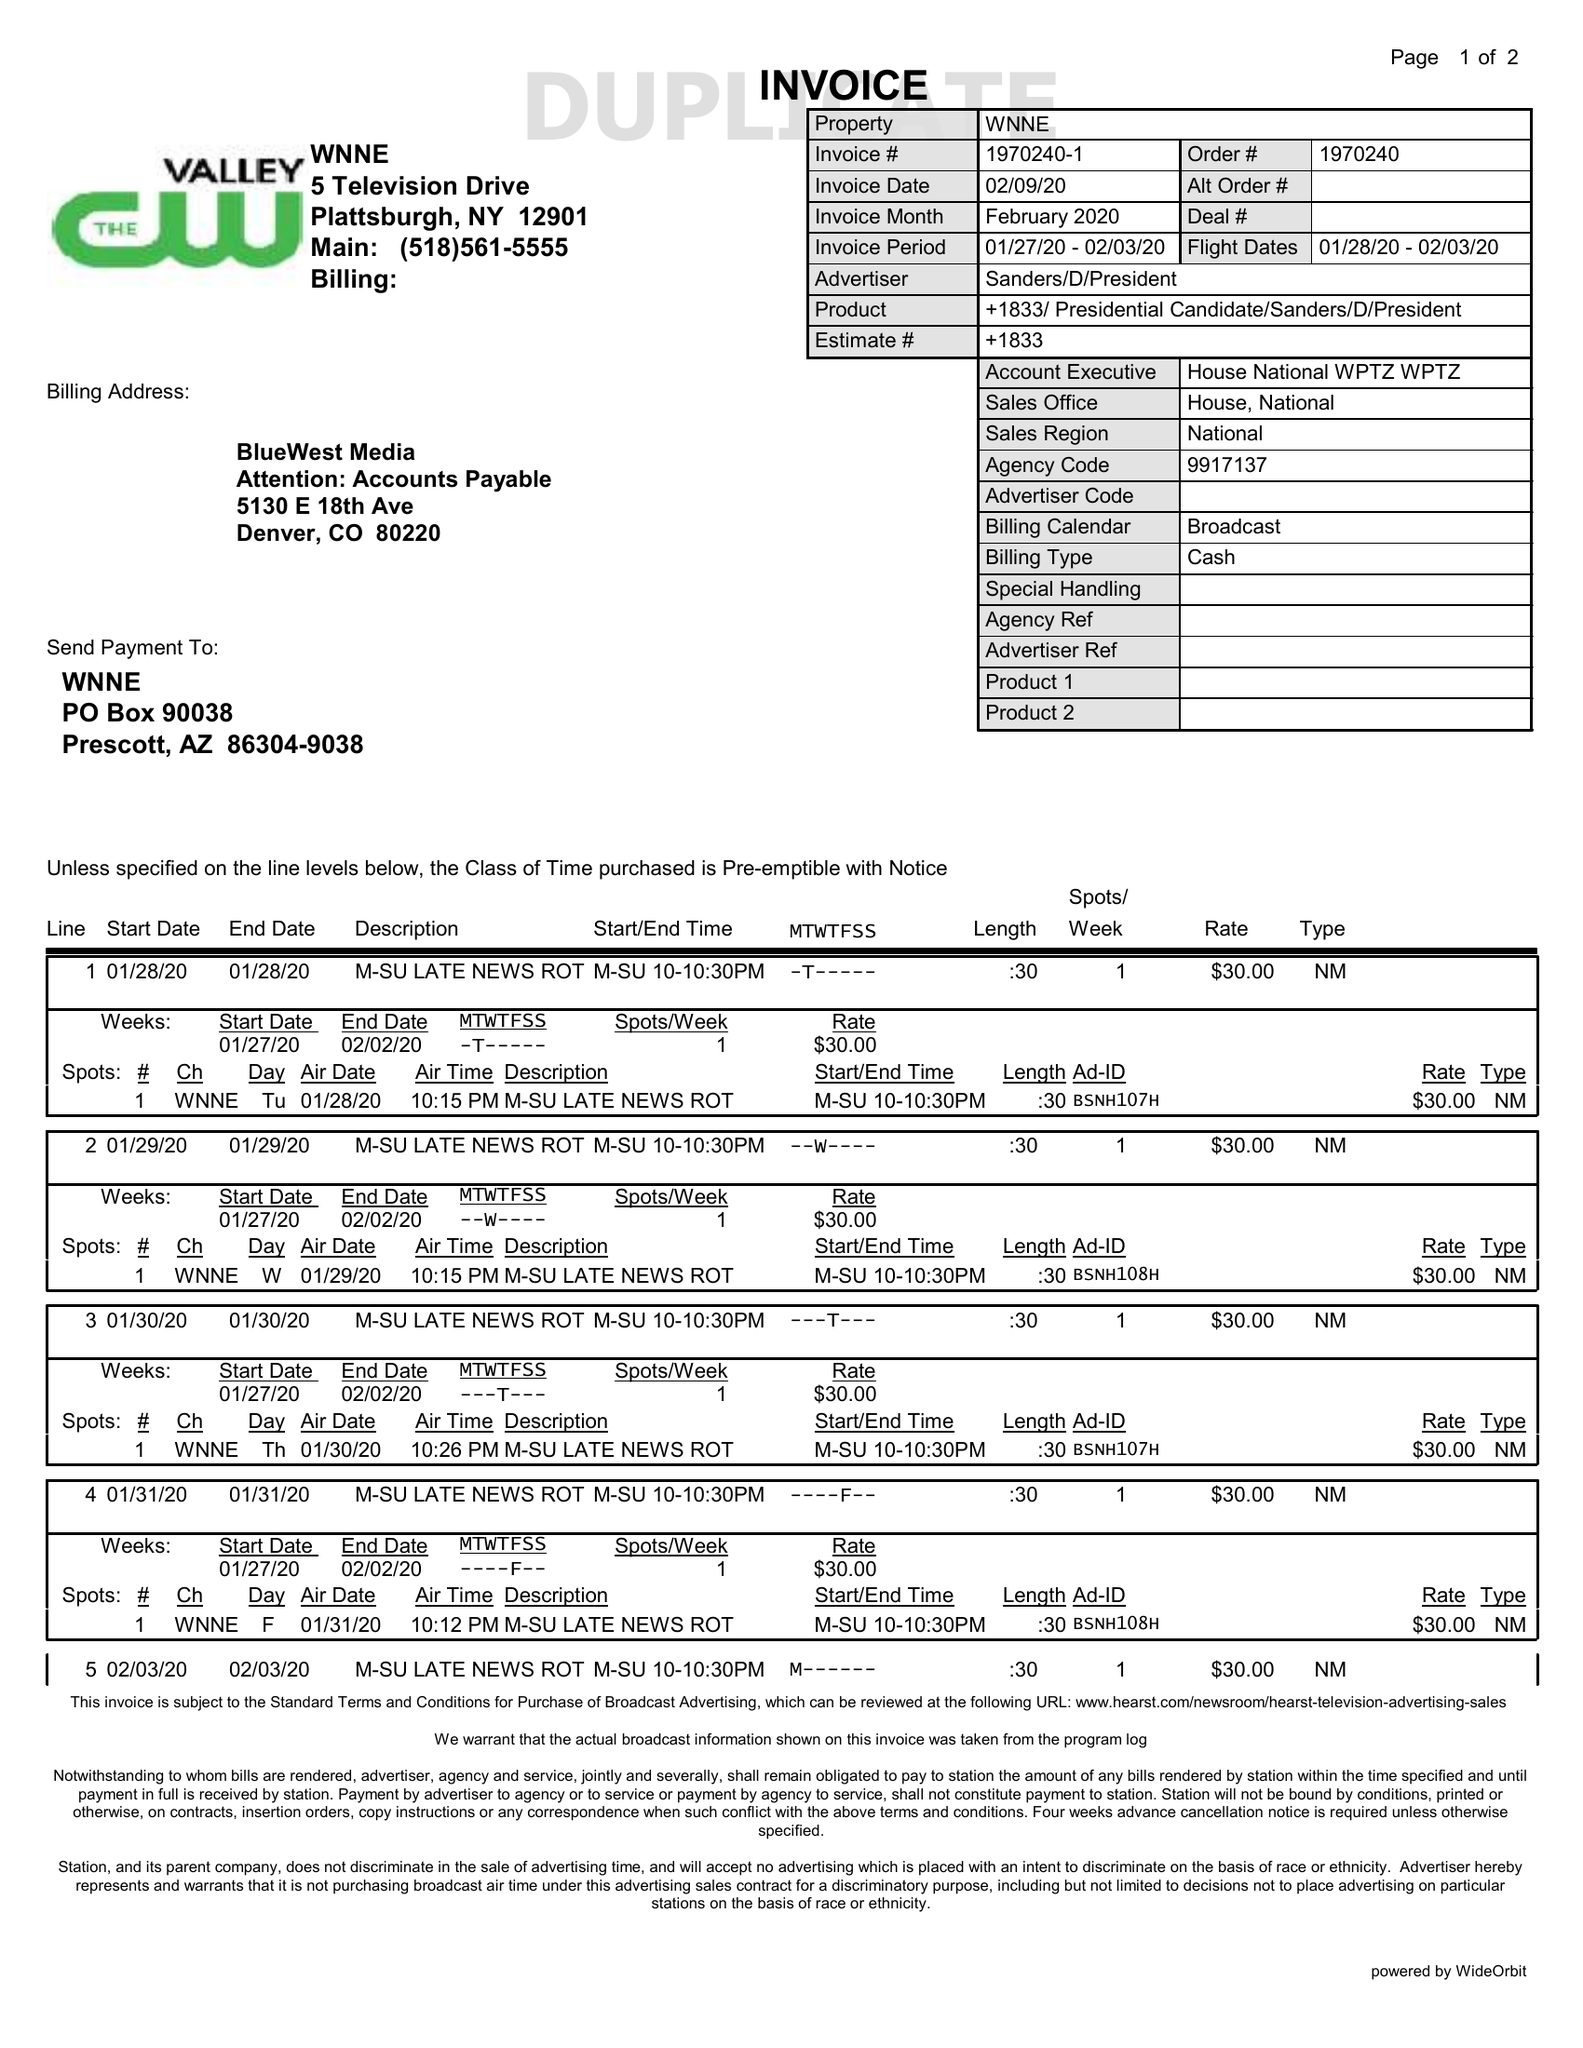What is the value for the gross_amount?
Answer the question using a single word or phrase. 210.00 